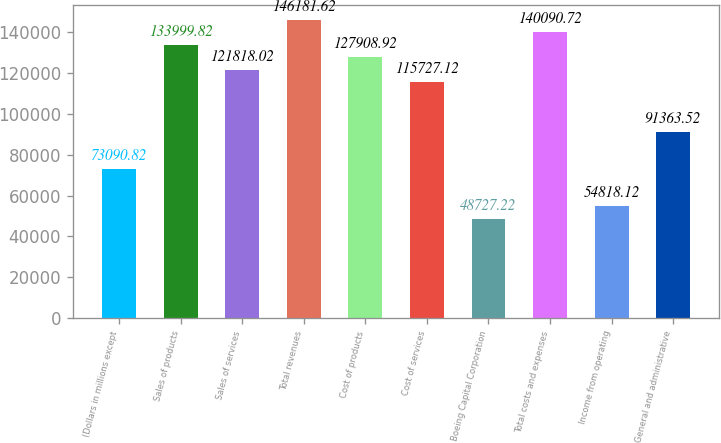Convert chart. <chart><loc_0><loc_0><loc_500><loc_500><bar_chart><fcel>(Dollars in millions except<fcel>Sales of products<fcel>Sales of services<fcel>Total revenues<fcel>Cost of products<fcel>Cost of services<fcel>Boeing Capital Corporation<fcel>Total costs and expenses<fcel>Income from operating<fcel>General and administrative<nl><fcel>73090.8<fcel>134000<fcel>121818<fcel>146182<fcel>127909<fcel>115727<fcel>48727.2<fcel>140091<fcel>54818.1<fcel>91363.5<nl></chart> 